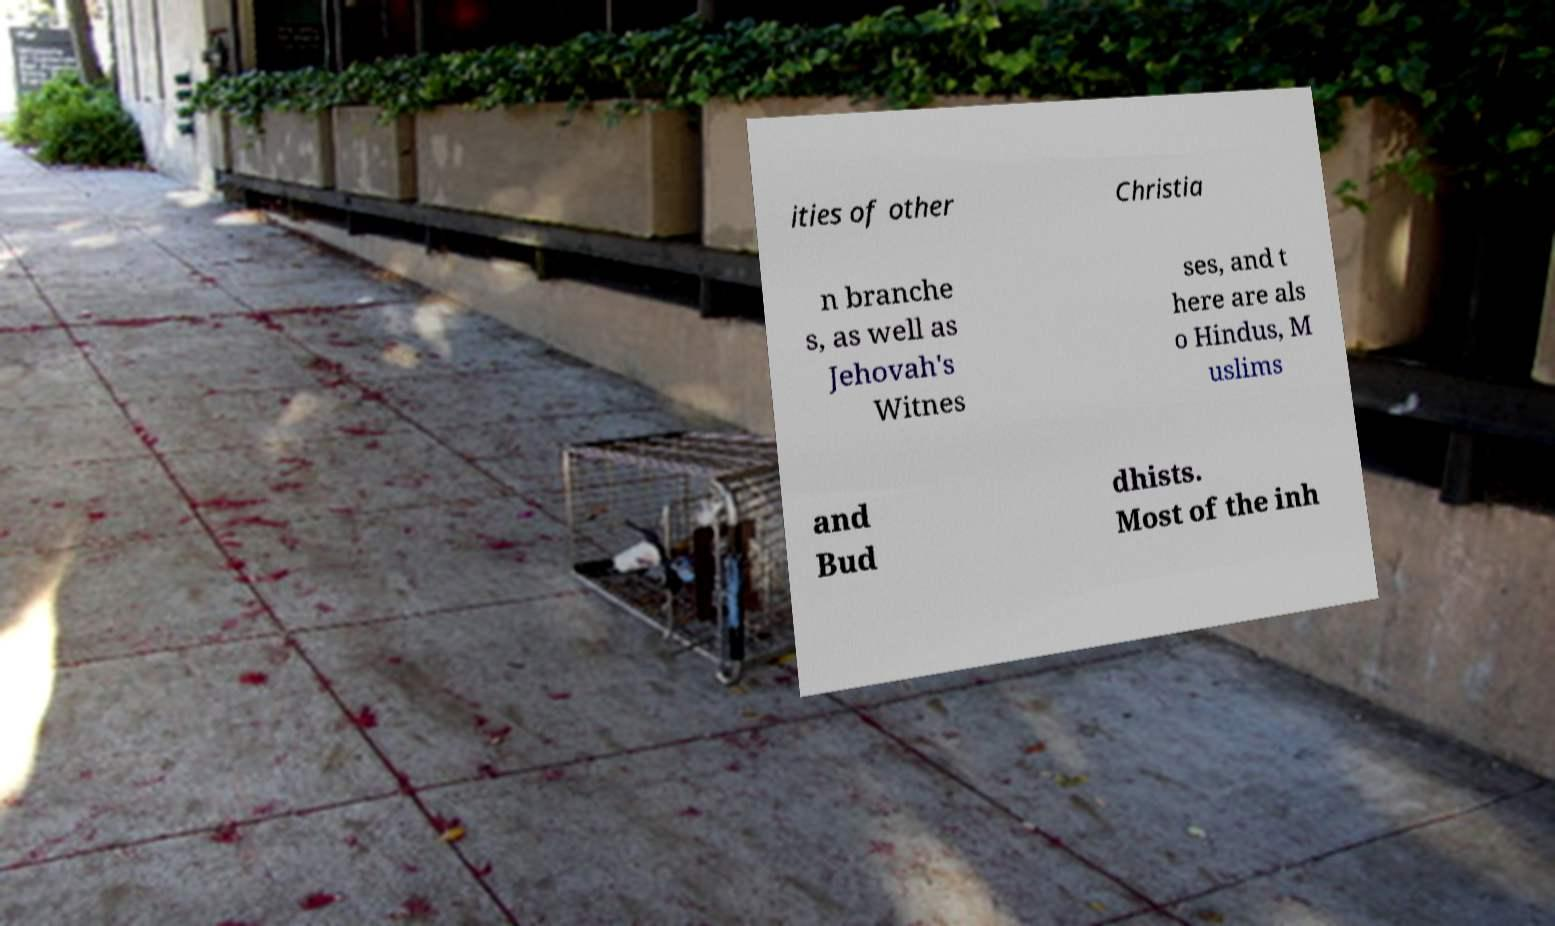Please identify and transcribe the text found in this image. ities of other Christia n branche s, as well as Jehovah's Witnes ses, and t here are als o Hindus, M uslims and Bud dhists. Most of the inh 